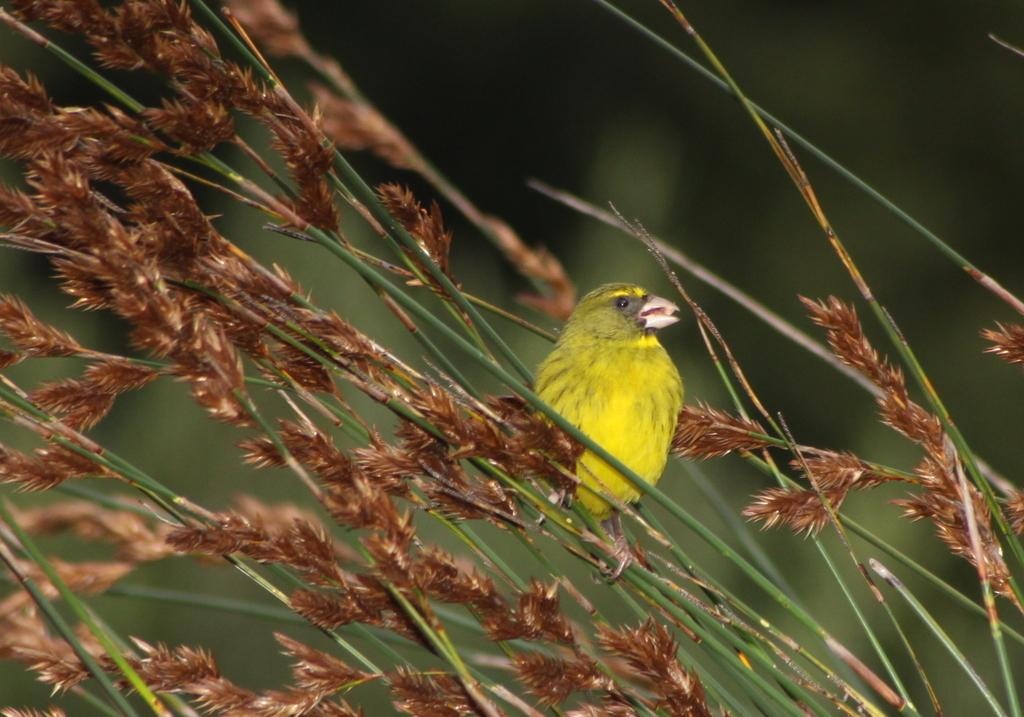What type of animal can be seen in the image? There is a bird in the image. What else is visible in the image besides the bird? There are stems and leaves visible in the image. Can you describe the background of the image? The background of the image is blurred. What type of hobbies does the bird have in the image? There is no information about the bird's hobbies in the image. Can you see any wounds on the bird in the image? There is no indication of any wounds on the bird in the image. 